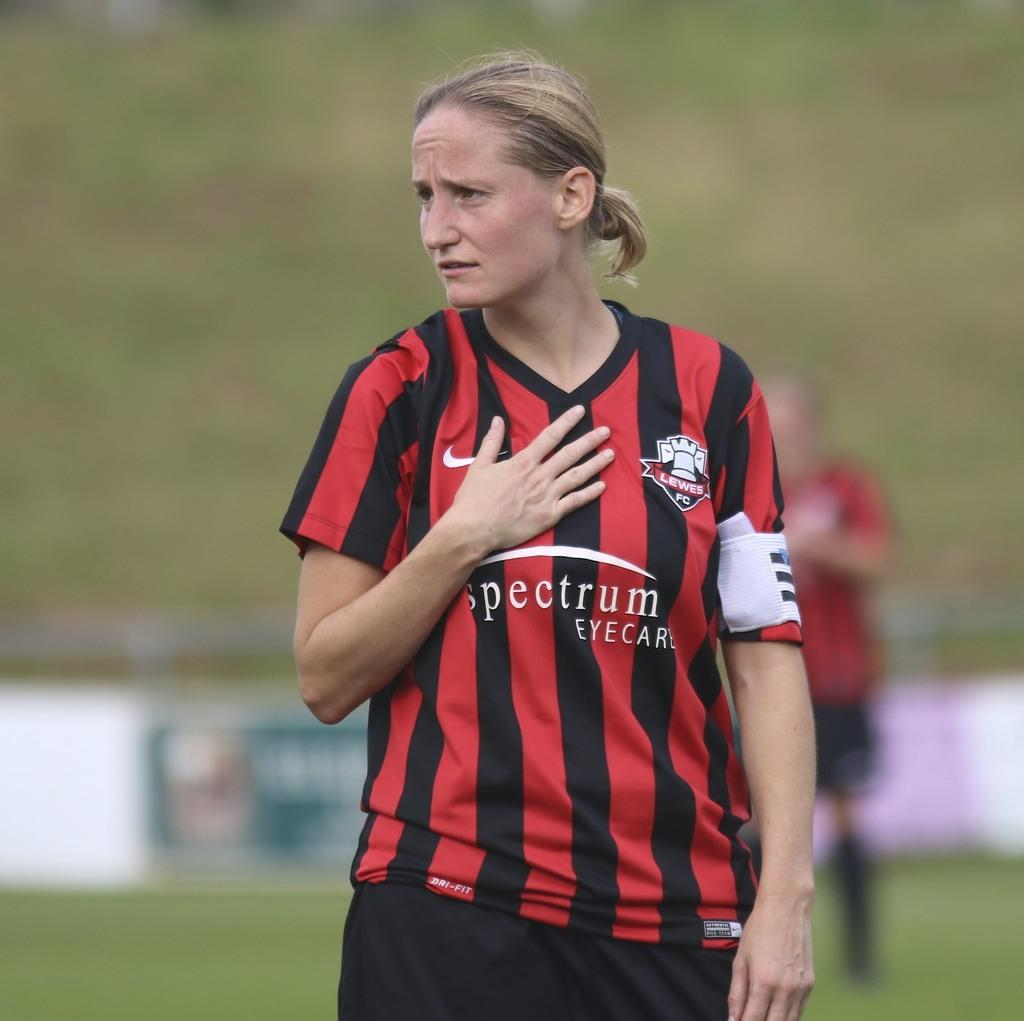<image>
Write a terse but informative summary of the picture. A girl has a jersey on with a Spectrum eye care logo on it. 